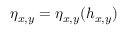<formula> <loc_0><loc_0><loc_500><loc_500>\eta _ { x , y } = \eta _ { x , y } ( h _ { x , y } )</formula> 